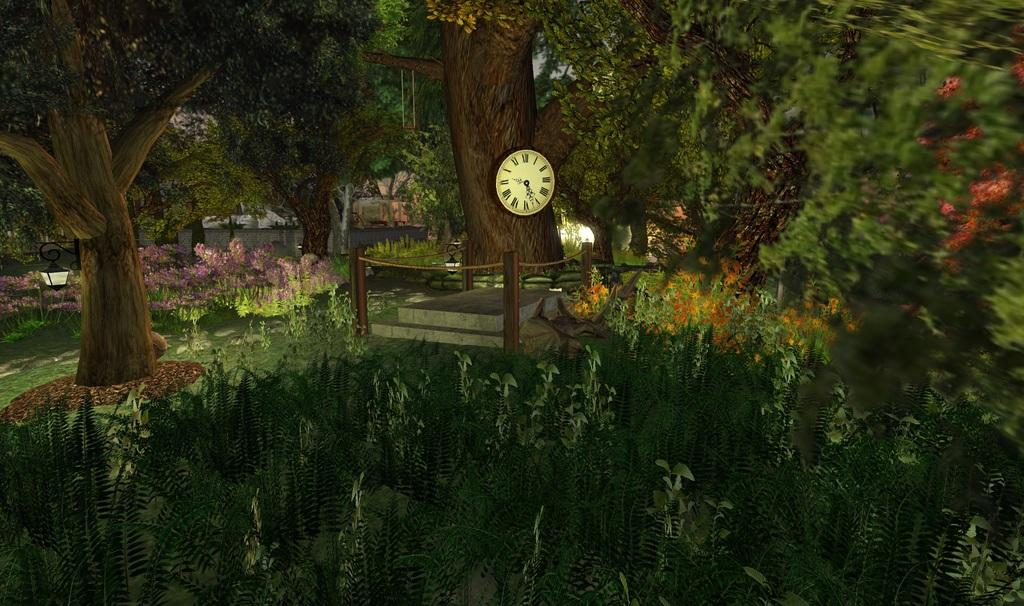What type of artwork is depicted in the image? The image is a painting. What natural elements can be seen in the painting? There are trees and plants in the painting. What man-made object is present in the painting? There is a clock in the painting. What type of material is the stone made of in the painting? The stone in the painting is made of a solid, natural material. What is used to illuminate the scene in the painting? There are lights in the painting. How is the stone protected or enclosed in the painting? There is a fence around the stone in the painting. What type of locket is hanging from the tree in the painting? There is no locket present in the painting; it only features trees, plants, a clock, a stone, lights, and a fence. 